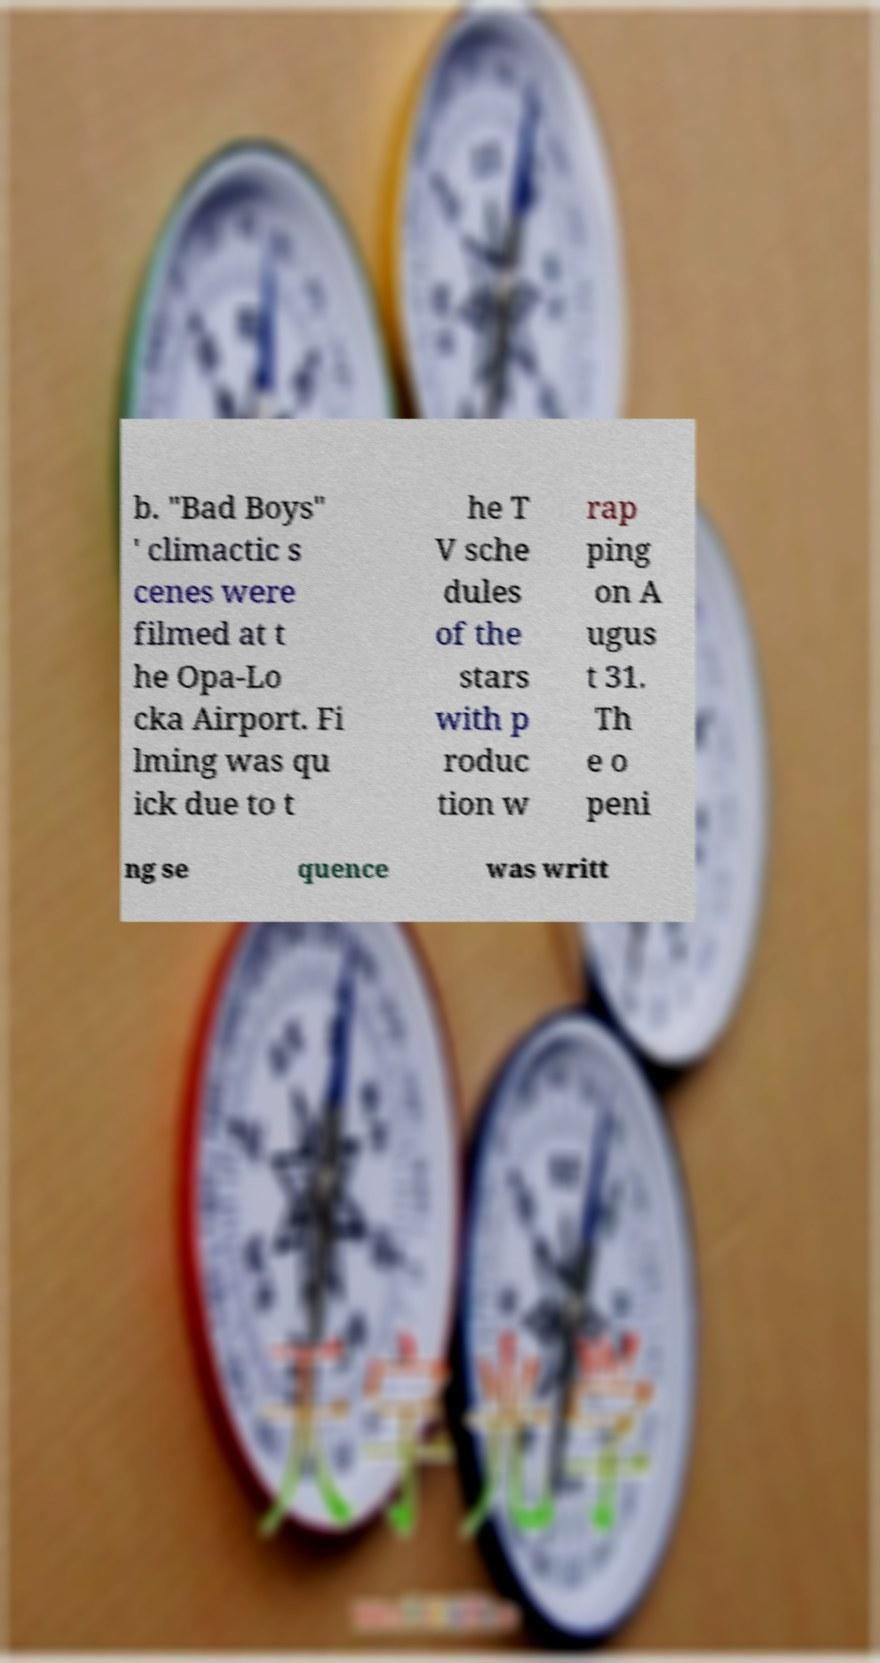Please identify and transcribe the text found in this image. b. "Bad Boys" ' climactic s cenes were filmed at t he Opa-Lo cka Airport. Fi lming was qu ick due to t he T V sche dules of the stars with p roduc tion w rap ping on A ugus t 31. Th e o peni ng se quence was writt 